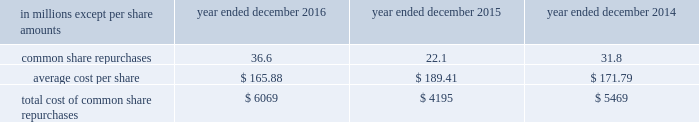The goldman sachs group , inc .
And subsidiaries notes to consolidated financial statements in connection with the firm 2019s prime brokerage and clearing businesses , the firm agrees to clear and settle on behalf of its clients the transactions entered into by them with other brokerage firms .
The firm 2019s obligations in respect of such transactions are secured by the assets in the client 2019s account as well as any proceeds received from the transactions cleared and settled by the firm on behalf of the client .
In connection with joint venture investments , the firm may issue loan guarantees under which it may be liable in the event of fraud , misappropriation , environmental liabilities and certain other matters involving the borrower .
The firm is unable to develop an estimate of the maximum payout under these guarantees and indemnifications .
However , management believes that it is unlikely the firm will have to make any material payments under these arrangements , and no material liabilities related to these guarantees and indemnifications have been recognized in the consolidated statements of financial condition as of december 2016 and december 2015 .
Other representations , warranties and indemnifications .
The firm provides representations and warranties to counterparties in connection with a variety of commercial transactions and occasionally indemnifies them against potential losses caused by the breach of those representations and warranties .
The firm may also provide indemnifications protecting against changes in or adverse application of certain u.s .
Tax laws in connection with ordinary-course transactions such as securities issuances , borrowings or derivatives .
In addition , the firm may provide indemnifications to some counterparties to protect them in the event additional taxes are owed or payments are withheld , due either to a change in or an adverse application of certain non-u.s .
Tax laws .
These indemnifications generally are standard contractual terms and are entered into in the ordinary course of business .
Generally , there are no stated or notional amounts included in these indemnifications , and the contingencies triggering the obligation to indemnify are not expected to occur .
The firm is unable to develop an estimate of the maximum payout under these guarantees and indemnifications .
However , management believes that it is unlikely the firm will have to make any material payments under these arrangements , and no material liabilities related to these arrangements have been recognized in the consolidated statements of financial condition as of december 2016 and december 2015 .
Guarantees of subsidiaries .
Group inc .
Fully and unconditionally guarantees the securities issued by gs finance corp. , a wholly-owned finance subsidiary of the group inc .
Has guaranteed the payment obligations of goldman , sachs & co .
( gs&co. ) and gs bank usa , subject to certain exceptions .
In addition , group inc .
Guarantees many of the obligations of its other consolidated subsidiaries on a transaction-by- transaction basis , as negotiated with counterparties .
Group inc .
Is unable to develop an estimate of the maximum payout under its subsidiary guarantees ; however , because these guaranteed obligations are also obligations of consolidated subsidiaries , group inc . 2019s liabilities as guarantor are not separately disclosed .
Note 19 .
Shareholders 2019 equity common equity dividends declared per common share were $ 2.60 in 2016 , $ 2.55 in 2015 and $ 2.25 in 2014 .
On january 17 , 2017 , group inc .
Declared a dividend of $ 0.65 per common share to be paid on march 30 , 2017 to common shareholders of record on march 2 , 2017 .
The firm 2019s share repurchase program is intended to help maintain the appropriate level of common equity .
The share repurchase program is effected primarily through regular open-market purchases ( which may include repurchase plans designed to comply with rule 10b5-1 ) , the amounts and timing of which are determined primarily by the firm 2019s current and projected capital position , but which may also be influenced by general market conditions and the prevailing price and trading volumes of the firm 2019s common stock .
Prior to repurchasing common stock , the firm must receive confirmation that the federal reserve board does not object to such capital actions .
The table below presents the amount of common stock repurchased by the firm under the share repurchase program. .
172 goldman sachs 2016 form 10-k .
What was the difference in millions between the total cost of common shares repurchases from 2015 to 2016? 
Computations: (6069 - 4195)
Answer: 1874.0. 